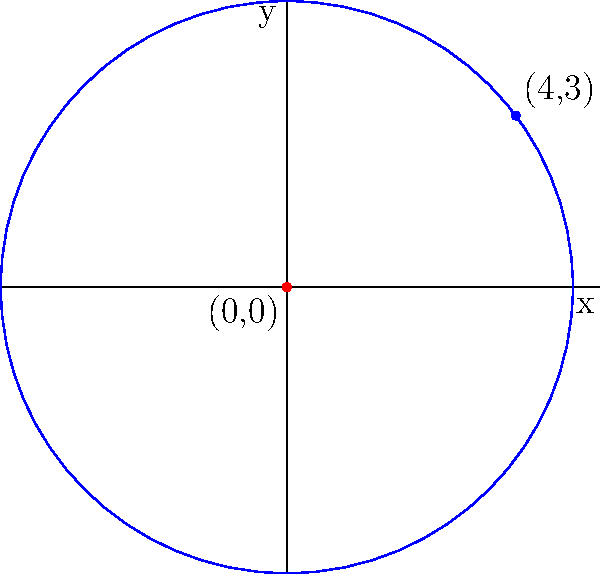Green Day's hit single "Boulevard of Broken Dreams" peaked at position (4,3) on a chart. Determine the equation of a circle with its center at the origin and passing through this point representing the song's chart position. To find the equation of a circle with its center at the origin (0,0) and passing through a point (4,3), we can follow these steps:

1. Recall the general equation of a circle with center (0,0):
   $$ x^2 + y^2 = r^2 $$
   where $r$ is the radius of the circle.

2. The radius of the circle is the distance from the center (0,0) to the point (4,3).

3. We can calculate this distance using the distance formula:
   $$ r = \sqrt{(x-0)^2 + (y-0)^2} = \sqrt{4^2 + 3^2} = \sqrt{16 + 9} = \sqrt{25} = 5 $$

4. Now that we know the radius, we can substitute it into the general equation:
   $$ x^2 + y^2 = 5^2 $$

5. Simplify:
   $$ x^2 + y^2 = 25 $$

This is the equation of the circle with its center at the origin and passing through the point (4,3), representing the chart position of "Boulevard of Broken Dreams".
Answer: $x^2 + y^2 = 25$ 